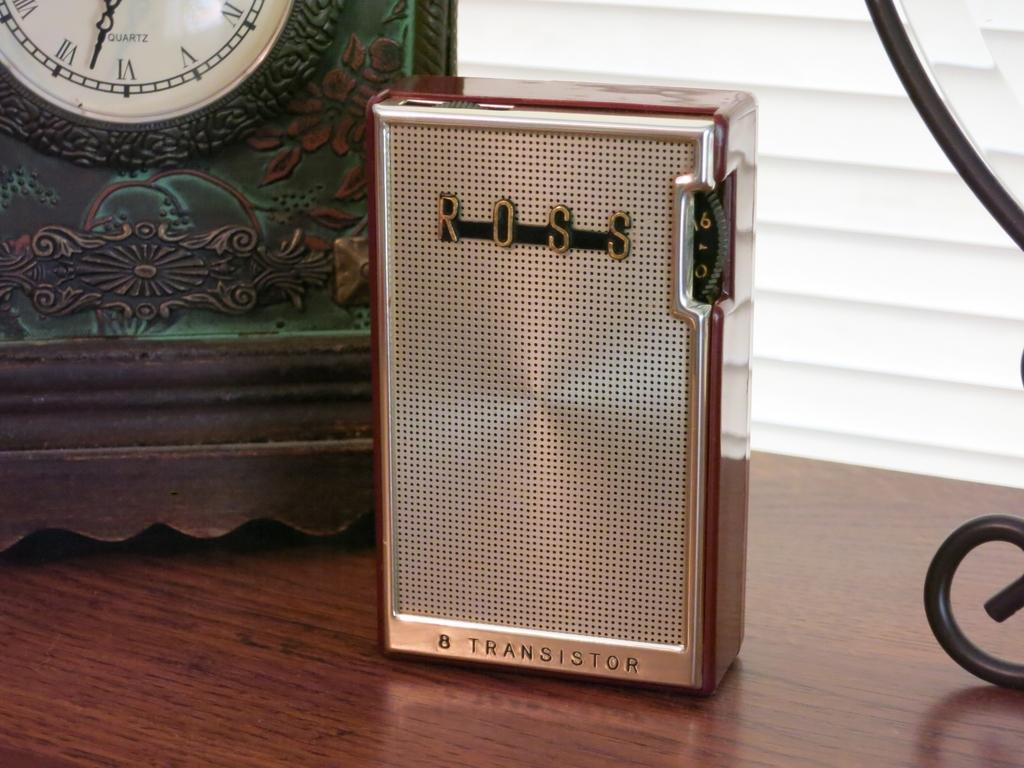<image>
Give a short and clear explanation of the subsequent image. A Ross transistor sits on a table next to a clock. 